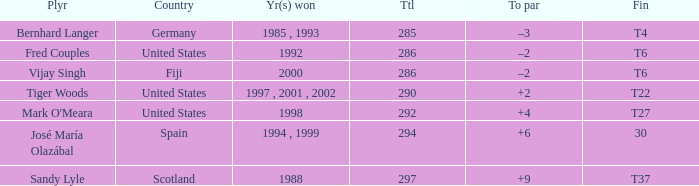What is the total of Mark O'meara? 292.0. 